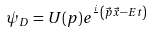Convert formula to latex. <formula><loc_0><loc_0><loc_500><loc_500>\psi _ { D } = U ( p ) e ^ { \frac { i } { } \left ( \vec { p } \vec { x } - E t \right ) }</formula> 